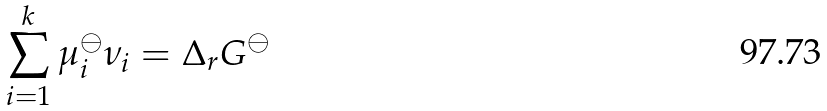<formula> <loc_0><loc_0><loc_500><loc_500>\sum _ { i = 1 } ^ { k } \mu _ { i } ^ { \ominus } \nu _ { i } = \Delta _ { r } G ^ { \ominus }</formula> 